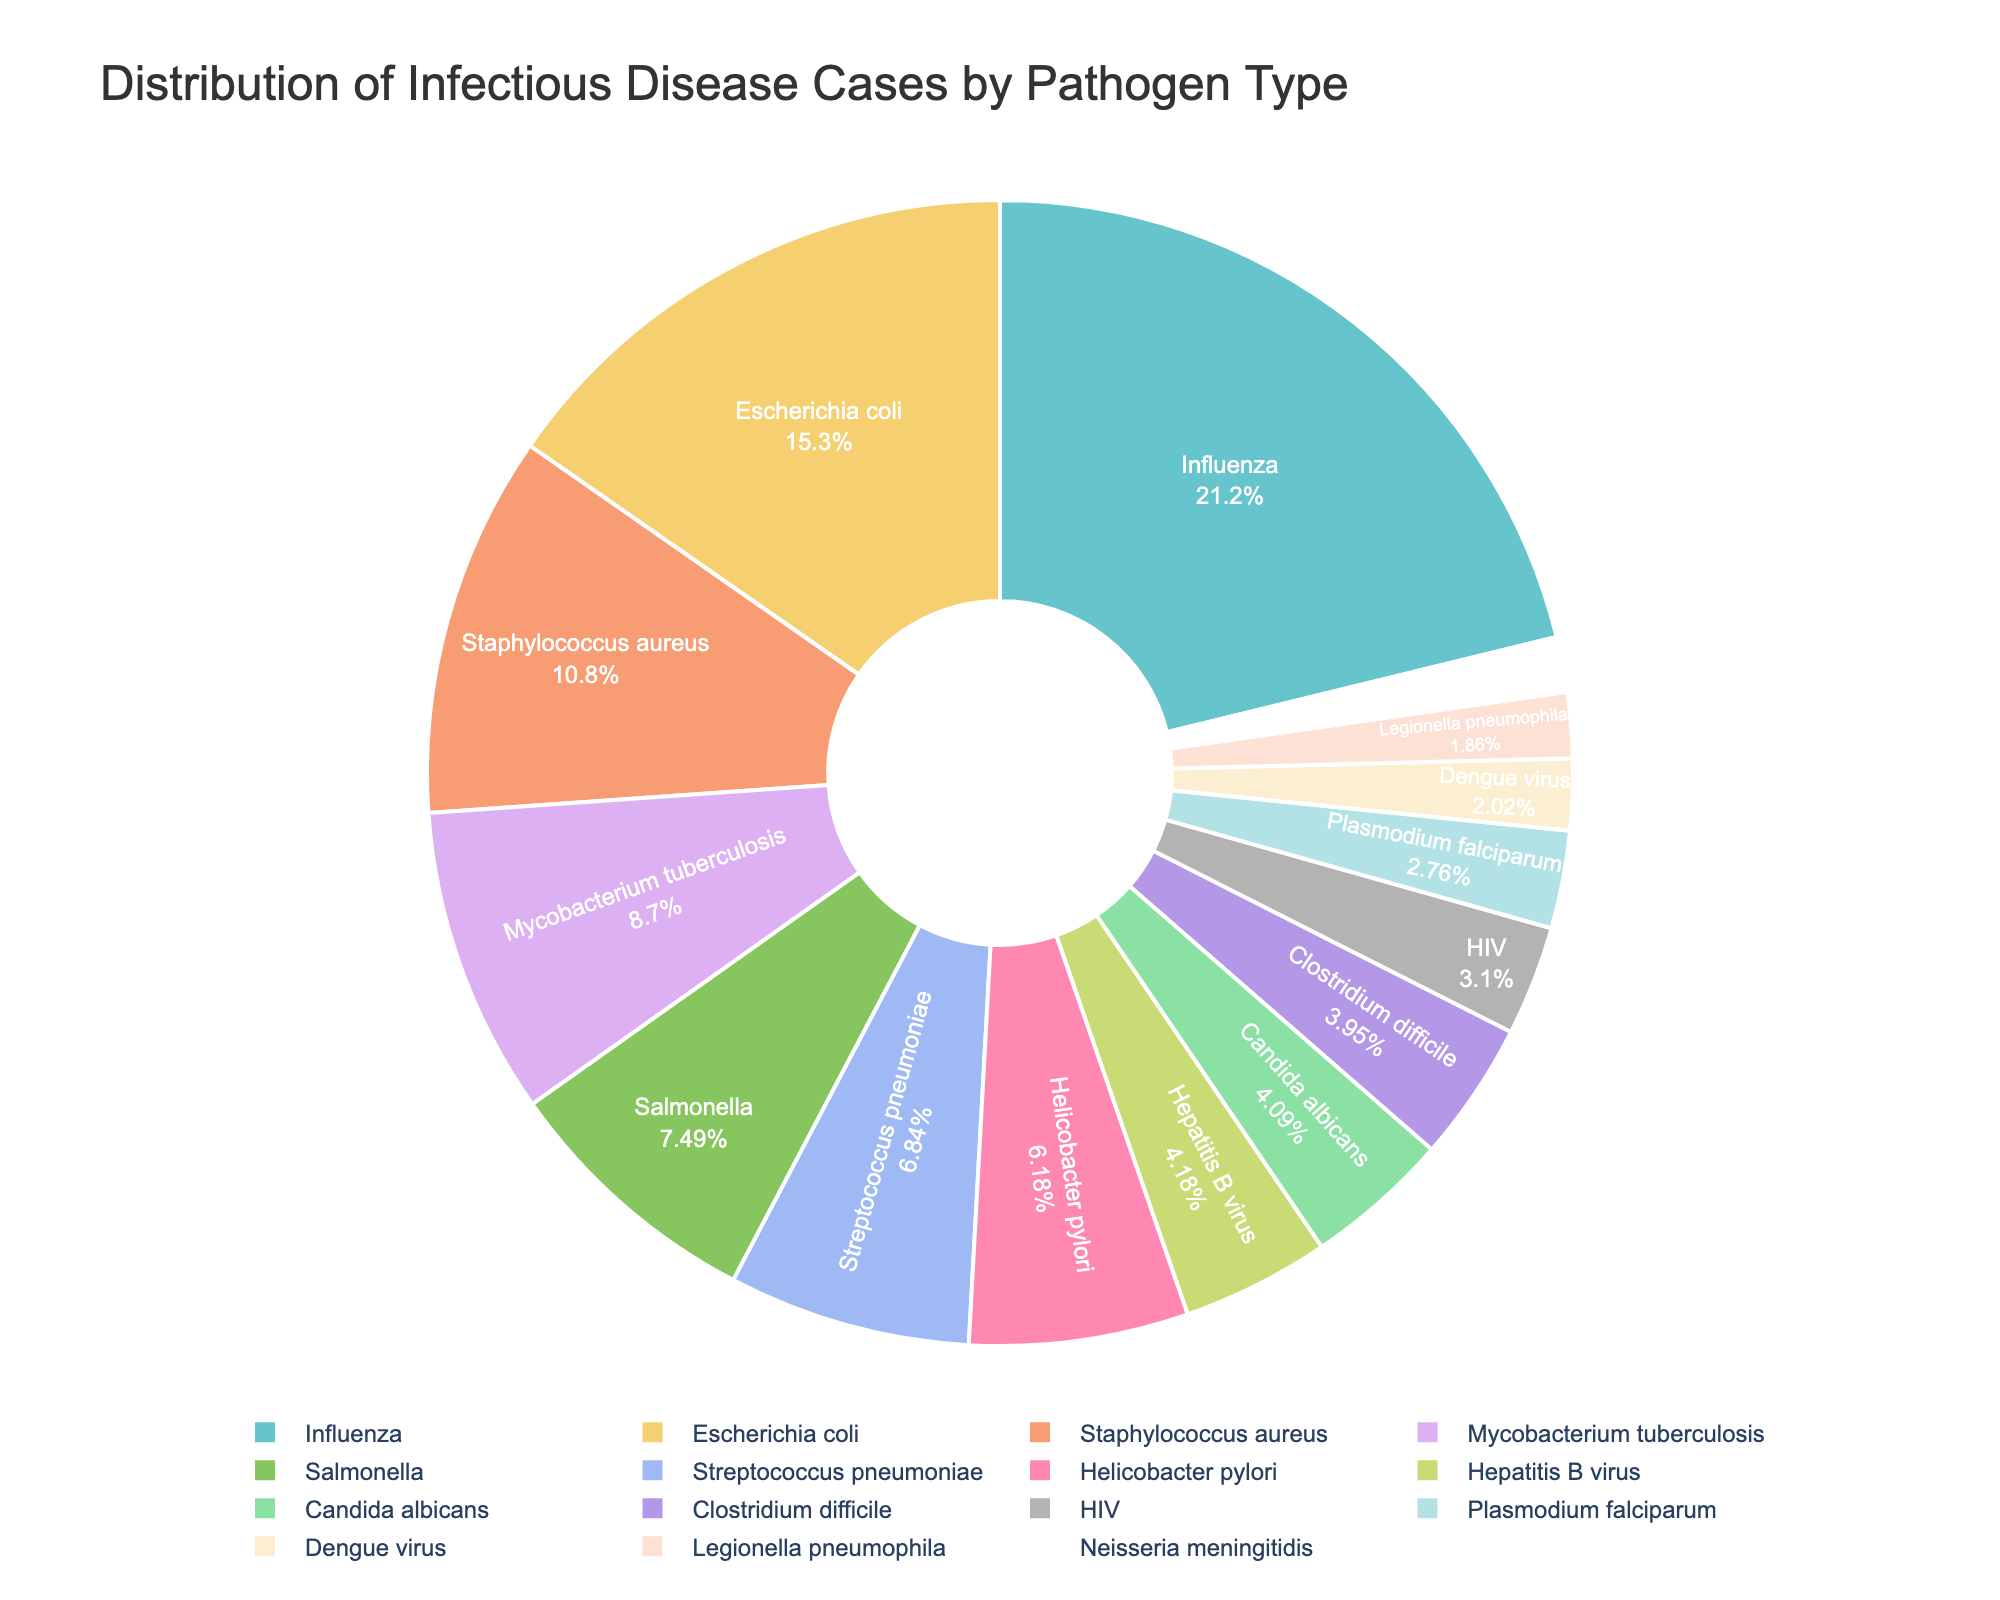What percentage of infectious disease cases are caused by Influenza? Find the section of the pie chart corresponding to Influenza and read the percentage value inside it.
Answer: 27.4% Which pathogen type has the smallest section in the pie chart? Identify the smallest section in the pie chart by visually comparing the sizes of all sections and find the label for that section.
Answer: Neisseria meningitidis How many more cases are caused by Escherichia coli compared to HIV? Find the values for Escherichia coli (1543 cases) and HIV (312 cases), then subtract the number of HIV cases from the number of Escherichia coli cases (1543 - 312 = 1231).
Answer: 1231 What is the total percentage of cases caused by Mycobacterium tuberculosis, Streptococcus pneumoniae, and Hepatitis B virus? Find the percentage values for Mycobacterium tuberculosis, Streptococcus pneumoniae, and Hepatitis B virus from the pie chart (11.3%, 8.9%, 5.4%, respectively), and sum them up (11.3 + 8.9 + 5.4 = 25.6).
Answer: 25.6% What color is used to represent Staphylococcus aureus in the pie chart? Locate the section of the pie chart labeled Staphylococcus aureus and identify its color.
Answer: Light Green Which pathogen types together cause more cases than Influenza alone? Identify the number of cases for Influenza (2134 cases). Then, find combinations of other pathogen types whose combined cases exceed 2134. For example, Staphylococcus aureus (1087) + Escherichia coli (1543) surpasses Influenza (1087 + 1543 = 2630).
Answer: Staphylococcus aureus and Escherichia coli Which pathogen type has a section that is almost twice the size of the Hepatitis B virus section? Identify the percentage value for Hepatitis B virus (5.4%) and find a section approximately twice that size (around 10.8%). Mycobacterium tuberculosis fits this description.
Answer: Mycobacterium tuberculosis What is the approximate combined percentage of cases caused by both Salmonella and Clostridium difficile? Find the percentage values for Salmonella and Clostridium difficile from the pie chart (9.7% and 5.1%, respectively), sum them up (9.7 + 5.1 = 14.8).
Answer: 14.8% Which pathogen type has a section rendered in blue? Locate the blue colored section in the pie chart and read the label for that section.
Answer: Escherichia coli 